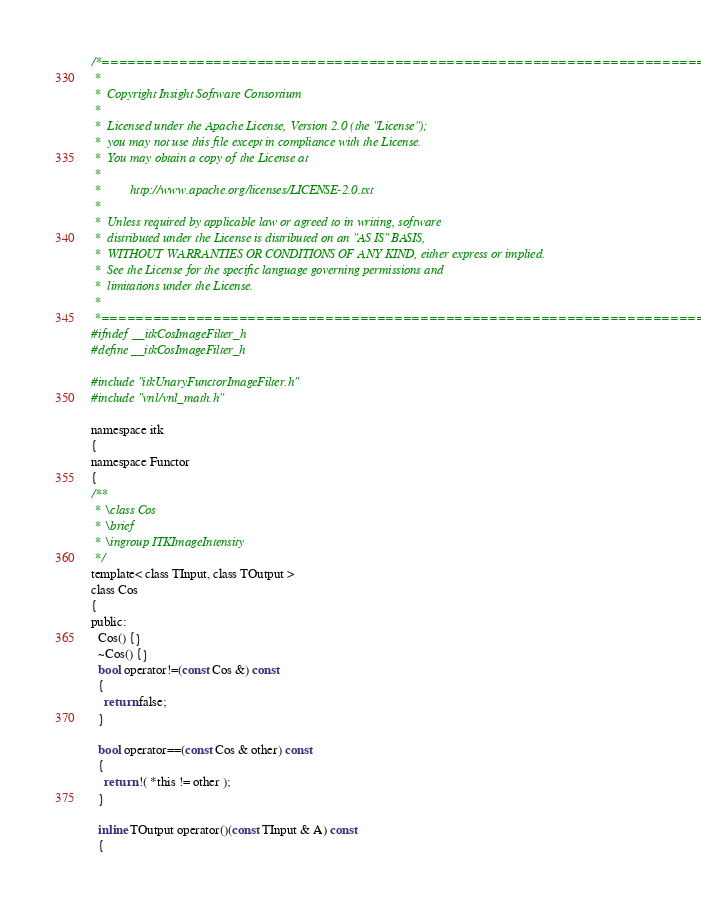<code> <loc_0><loc_0><loc_500><loc_500><_C_>/*=========================================================================
 *
 *  Copyright Insight Software Consortium
 *
 *  Licensed under the Apache License, Version 2.0 (the "License");
 *  you may not use this file except in compliance with the License.
 *  You may obtain a copy of the License at
 *
 *         http://www.apache.org/licenses/LICENSE-2.0.txt
 *
 *  Unless required by applicable law or agreed to in writing, software
 *  distributed under the License is distributed on an "AS IS" BASIS,
 *  WITHOUT WARRANTIES OR CONDITIONS OF ANY KIND, either express or implied.
 *  See the License for the specific language governing permissions and
 *  limitations under the License.
 *
 *=========================================================================*/
#ifndef __itkCosImageFilter_h
#define __itkCosImageFilter_h

#include "itkUnaryFunctorImageFilter.h"
#include "vnl/vnl_math.h"

namespace itk
{
namespace Functor
{
/**
 * \class Cos
 * \brief
 * \ingroup ITKImageIntensity
 */
template< class TInput, class TOutput >
class Cos
{
public:
  Cos() {}
  ~Cos() {}
  bool operator!=(const Cos &) const
  {
    return false;
  }

  bool operator==(const Cos & other) const
  {
    return !( *this != other );
  }

  inline TOutput operator()(const TInput & A) const
  {</code> 